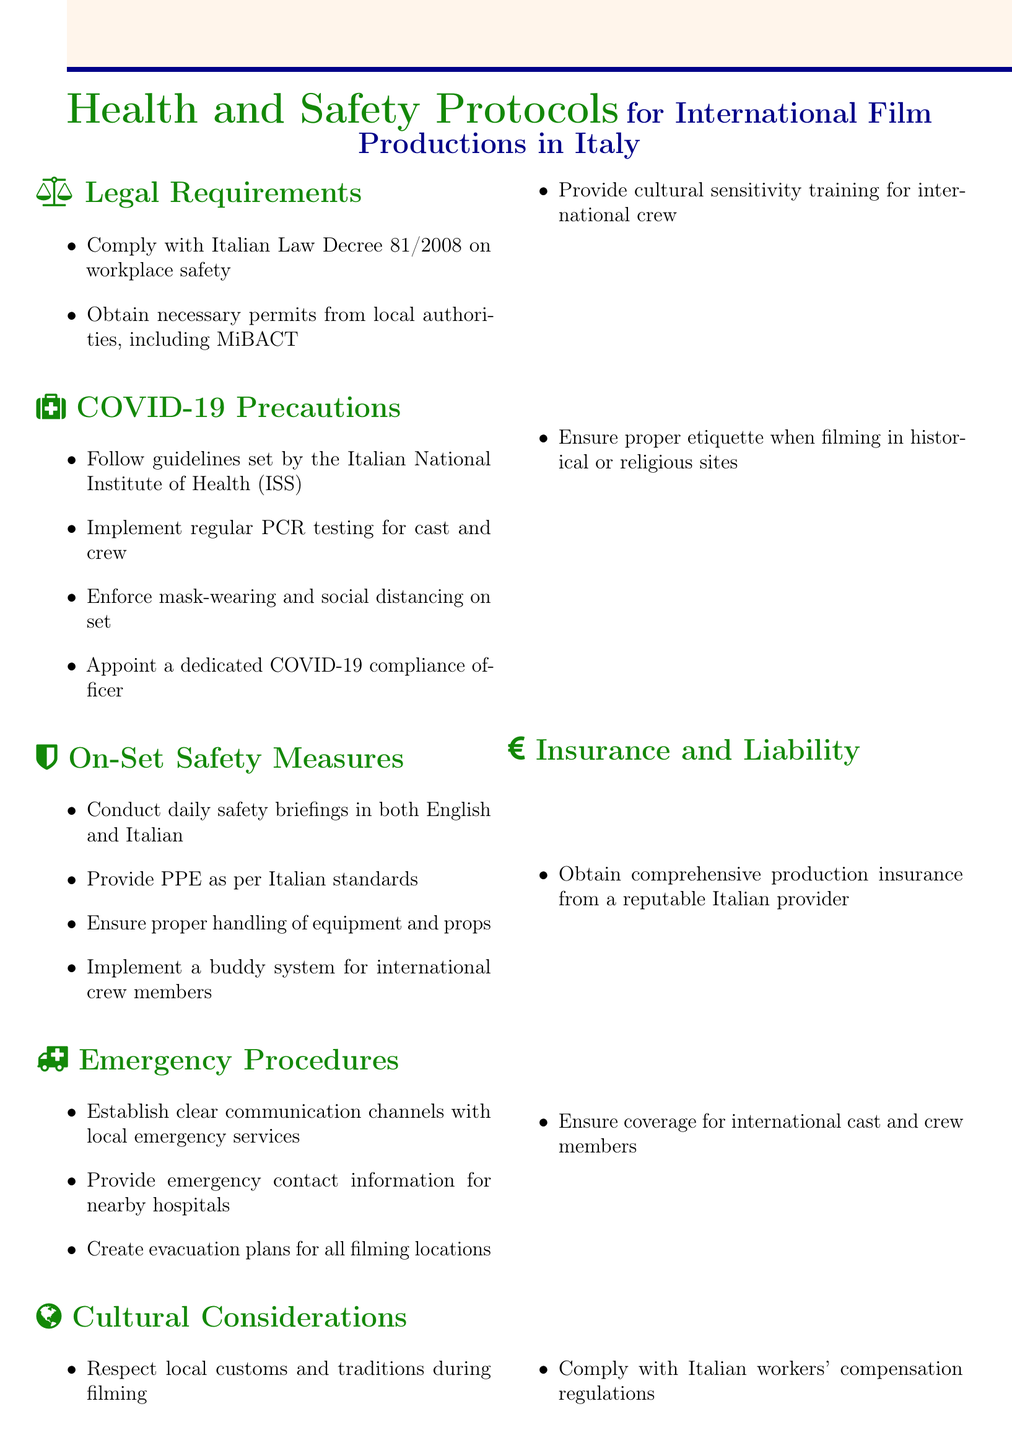what is the legal decree mentioned for workplace safety? The document mentions Italian Law Decree 81/2008 as the legal requirement for workplace safety.
Answer: Italian Law Decree 81/2008 how often should PCR testing be implemented for cast and crew? The document specifies regular PCR testing for cast and crew but does not define a frequency; however, "regular" typically implies frequent testing.
Answer: Regularly who should be appointed as a COVID-19 compliance officer? The document states that a dedicated COVID-19 compliance officer must be appointed to ensure adherence to health guidelines.
Answer: Dedicated COVID-19 compliance officer what kind of training should be provided for international crew members? Cultural sensitivity training should be provided for international crew members in order to respect local customs and traditions during filming.
Answer: Cultural sensitivity training what kind of insurance is required for production? The document specifies that comprehensive production insurance from a reputable Italian provider is required.
Answer: Comprehensive production insurance what is one of the safety measures to be conducted daily on set? Daily safety briefings in both English and Italian are required as part of the on-set safety measures.
Answer: Daily safety briefings what action should be taken to handle emergencies? The document outlines the need to establish clear communication channels with local emergency services as part of emergency procedures.
Answer: Clear communication channels what must be respected during filming related to cultural aspects? The document emphasizes the importance of respecting local customs and traditions during filming.
Answer: Local customs and traditions what is crucial for proper etiquette in historical or religious sites? Ensuring proper etiquette when filming in historical or religious sites is crucial as per the guidelines in the document.
Answer: Proper etiquette 